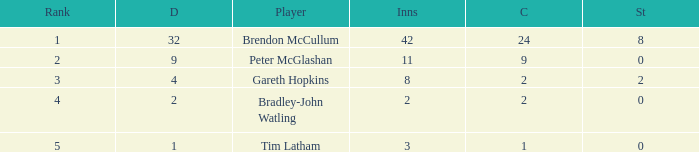Can you provide the count of stumpings tim latham achieved in his career? 0.0. 